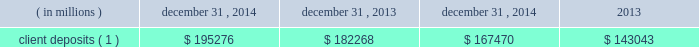Management 2019s discussion and analysis of financial condition and results of operations ( continued ) funding deposits : we provide products and services including custody , accounting , administration , daily pricing , foreign exchange services , cash management , financial asset management , securities finance and investment advisory services .
As a provider of these products and services , we generate client deposits , which have generally provided a stable , low-cost source of funds .
As a global custodian , clients place deposits with state street entities in various currencies .
We invest these client deposits in a combination of investment securities and short- duration financial instruments whose mix is determined by the characteristics of the deposits .
For the past several years , we have experienced higher client deposit inflows toward the end of the quarter or the end of the year .
As a result , we believe average client deposit balances are more reflective of ongoing funding than period-end balances .
Table 33 : client deposits average balance december 31 , year ended december 31 .
Client deposits ( 1 ) $ 195276 $ 182268 $ 167470 $ 143043 ( 1 ) balance as of december 31 , 2014 excluded term wholesale certificates of deposit , or cds , of $ 13.76 billion ; average balances for the year ended december 31 , 2014 and 2013 excluded average cds of $ 6.87 billion and $ 2.50 billion , respectively .
Short-term funding : our corporate commercial paper program , under which we can issue up to $ 3.0 billion of commercial paper with original maturities of up to 270 days from the date of issuance , had $ 2.48 billion and $ 1.82 billion of commercial paper outstanding as of december 31 , 2014 and 2013 , respectively .
Our on-balance sheet liquid assets are also an integral component of our liquidity management strategy .
These assets provide liquidity through maturities of the assets , but more importantly , they provide us with the ability to raise funds by pledging the securities as collateral for borrowings or through outright sales .
In addition , our access to the global capital markets gives us the ability to source incremental funding at reasonable rates of interest from wholesale investors .
As discussed earlier under 201casset liquidity , 201d state street bank's membership in the fhlb allows for advances of liquidity with varying terms against high-quality collateral .
Short-term secured funding also comes in the form of securities lent or sold under agreements to repurchase .
These transactions are short-term in nature , generally overnight , and are collateralized by high-quality investment securities .
These balances were $ 8.93 billion and $ 7.95 billion as of december 31 , 2014 and 2013 , respectively .
State street bank currently maintains a line of credit with a financial institution of cad $ 800 million , or approximately $ 690 million as of december 31 , 2014 , to support its canadian securities processing operations .
The line of credit has no stated termination date and is cancelable by either party with prior notice .
As of december 31 , 2014 , there was no balance outstanding on this line of credit .
Long-term funding : as of december 31 , 2014 , state street bank had board authority to issue unsecured senior debt securities from time to time , provided that the aggregate principal amount of such unsecured senior debt outstanding at any one time does not exceed $ 5 billion .
As of december 31 , 2014 , $ 4.1 billion was available for issuance pursuant to this authority .
As of december 31 , 2014 , state street bank also had board authority to issue an additional $ 500 million of subordinated debt .
We maintain an effective universal shelf registration that allows for the public offering and sale of debt securities , capital securities , common stock , depositary shares and preferred stock , and warrants to purchase such securities , including any shares into which the preferred stock and depositary shares may be convertible , or any combination thereof .
We have issued in the past , and we may issue in the future , securities pursuant to our shelf registration .
The issuance of debt or equity securities will depend on future market conditions , funding needs and other factors .
Agency credit ratings our ability to maintain consistent access to liquidity is fostered by the maintenance of high investment-grade ratings as measured by the major independent credit rating agencies .
Factors essential to maintaining high credit ratings include diverse and stable core earnings ; relative market position ; strong risk management ; strong capital ratios ; diverse liquidity sources , including the global capital markets and client deposits ; strong liquidity monitoring procedures ; and preparedness for current or future regulatory developments .
High ratings limit borrowing costs and enhance our liquidity by providing assurance for unsecured funding and depositors , increasing the potential market for our debt and improving our ability to offer products , serve markets , and engage in transactions in which clients value high credit ratings .
A downgrade or reduction of our credit ratings could have a material adverse effect on our liquidity by restricting our ability to access the capital .
What is the growth rate in the deposits of clients from 2012 to 2013? 
Computations: ((182268 - 167470) / 167470)
Answer: 0.08836. 